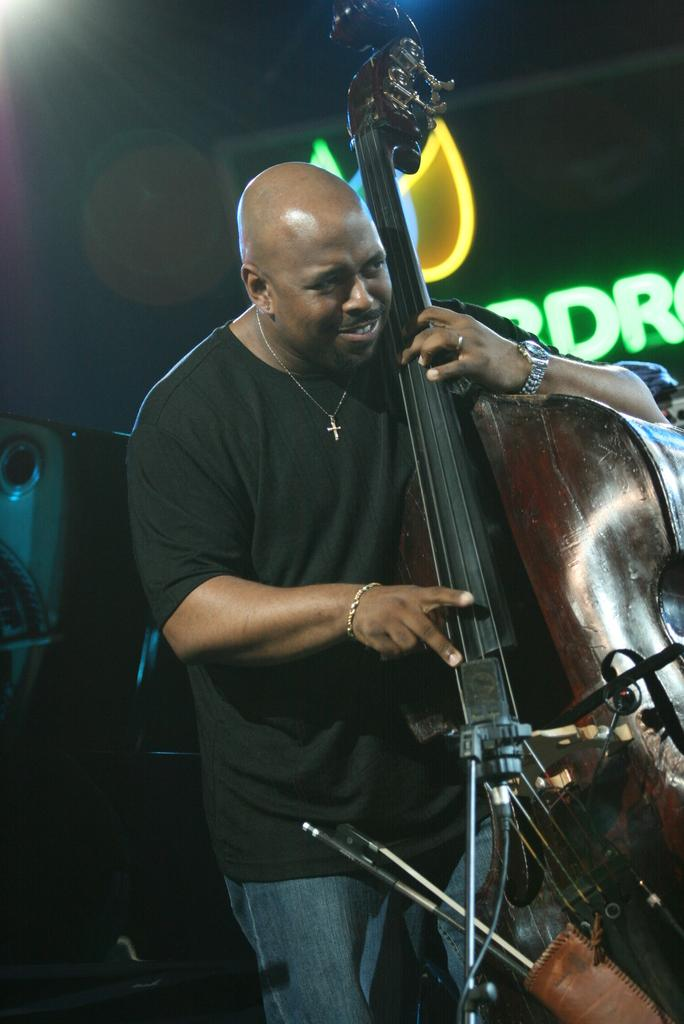What is the main subject of the image? There is a person standing in the image. What is the person wearing? The person is wearing a black t-shirt. What is the person holding in the image? The person is holding a guitar in his hands. How many clocks can be seen on the person's feet in the image? There are no clocks visible on the person's feet in the image. What type of sock is the person wearing with their guitar? The person is not wearing any socks in the image, as they are wearing shoes. 